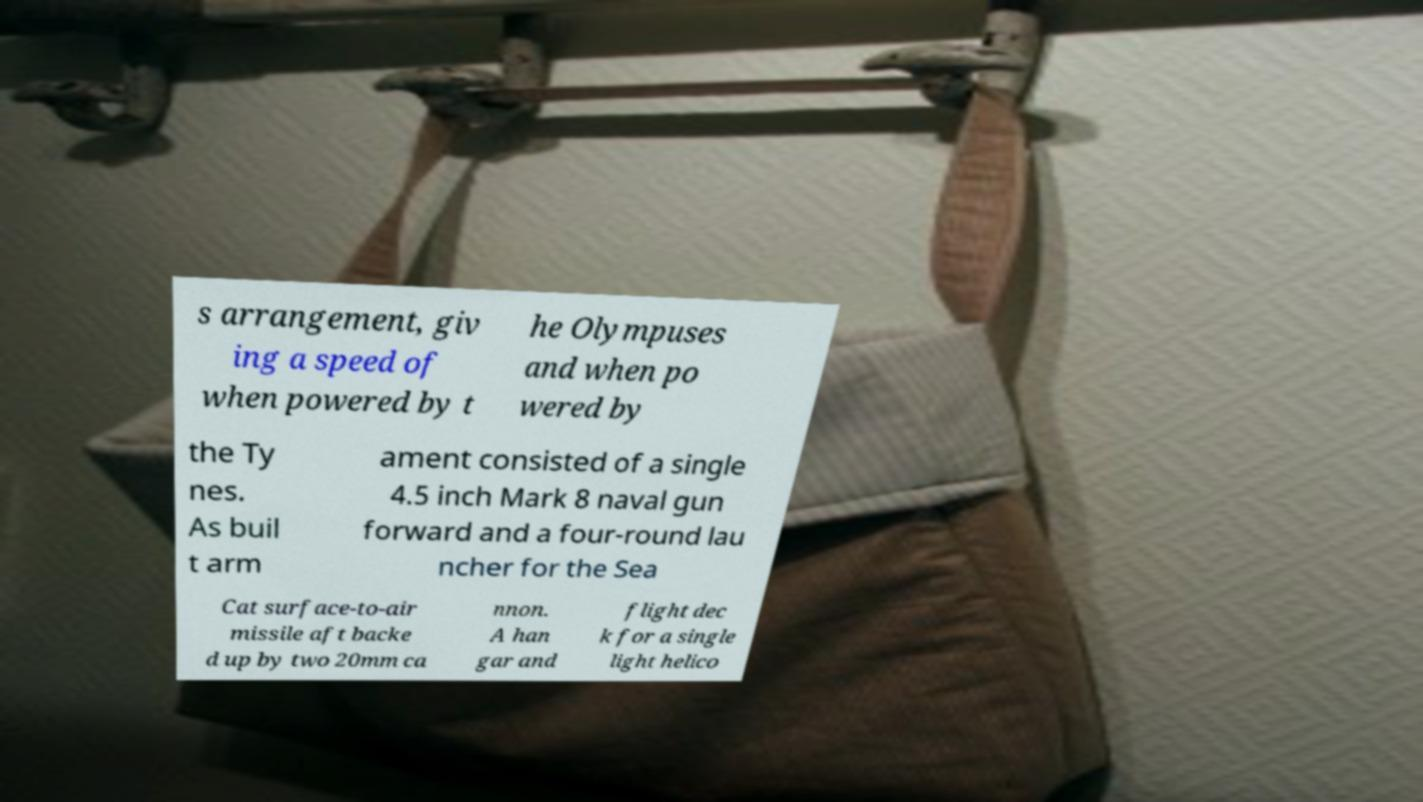Can you read and provide the text displayed in the image?This photo seems to have some interesting text. Can you extract and type it out for me? s arrangement, giv ing a speed of when powered by t he Olympuses and when po wered by the Ty nes. As buil t arm ament consisted of a single 4.5 inch Mark 8 naval gun forward and a four-round lau ncher for the Sea Cat surface-to-air missile aft backe d up by two 20mm ca nnon. A han gar and flight dec k for a single light helico 